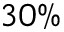<formula> <loc_0><loc_0><loc_500><loc_500>3 0 \%</formula> 